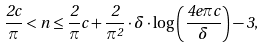Convert formula to latex. <formula><loc_0><loc_0><loc_500><loc_500>\frac { 2 c } { \pi } < n \leq \frac { 2 } { \pi } c + \frac { 2 } { \pi ^ { 2 } } \cdot \delta \cdot \log \left ( \frac { 4 e \pi c } { \delta } \right ) - 3 ,</formula> 